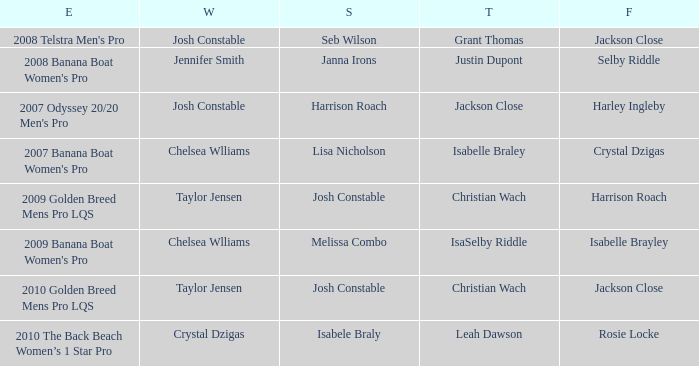Who was the Winner when Selby Riddle came in Fourth? Jennifer Smith. 